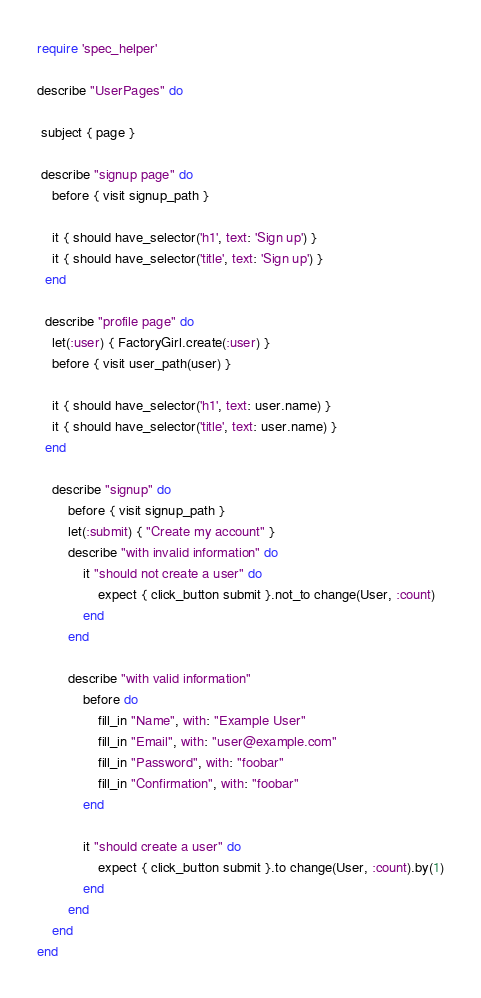Convert code to text. <code><loc_0><loc_0><loc_500><loc_500><_Ruby_>require 'spec_helper'

describe "UserPages" do
 
 subject { page }

 describe "signup page" do
 	before { visit signup_path }

 	it { should have_selector('h1', text: 'Sign up') }
 	it { should have_selector('title', text: 'Sign up') }
  end

  describe "profile page" do
  	let(:user) { FactoryGirl.create(:user) }
  	before { visit user_path(user) }

  	it { should have_selector('h1', text: user.name) }
  	it { should have_selector('title', text: user.name) }
  end

	describe "signup" do
		before { visit signup_path }
		let(:submit) { "Create my account" }
		describe "with invalid information" do
			it "should not create a user" do
				expect { click_button submit }.not_to change(User, :count)
			end
		end

		describe "with valid information"
			before do
				fill_in "Name", with: "Example User"
				fill_in "Email", with: "user@example.com"
				fill_in "Password", with: "foobar"
				fill_in "Confirmation", with: "foobar"
			end

			it "should create a user" do
				expect { click_button submit }.to change(User, :count).by(1)
			end
		end
	end
end
</code> 